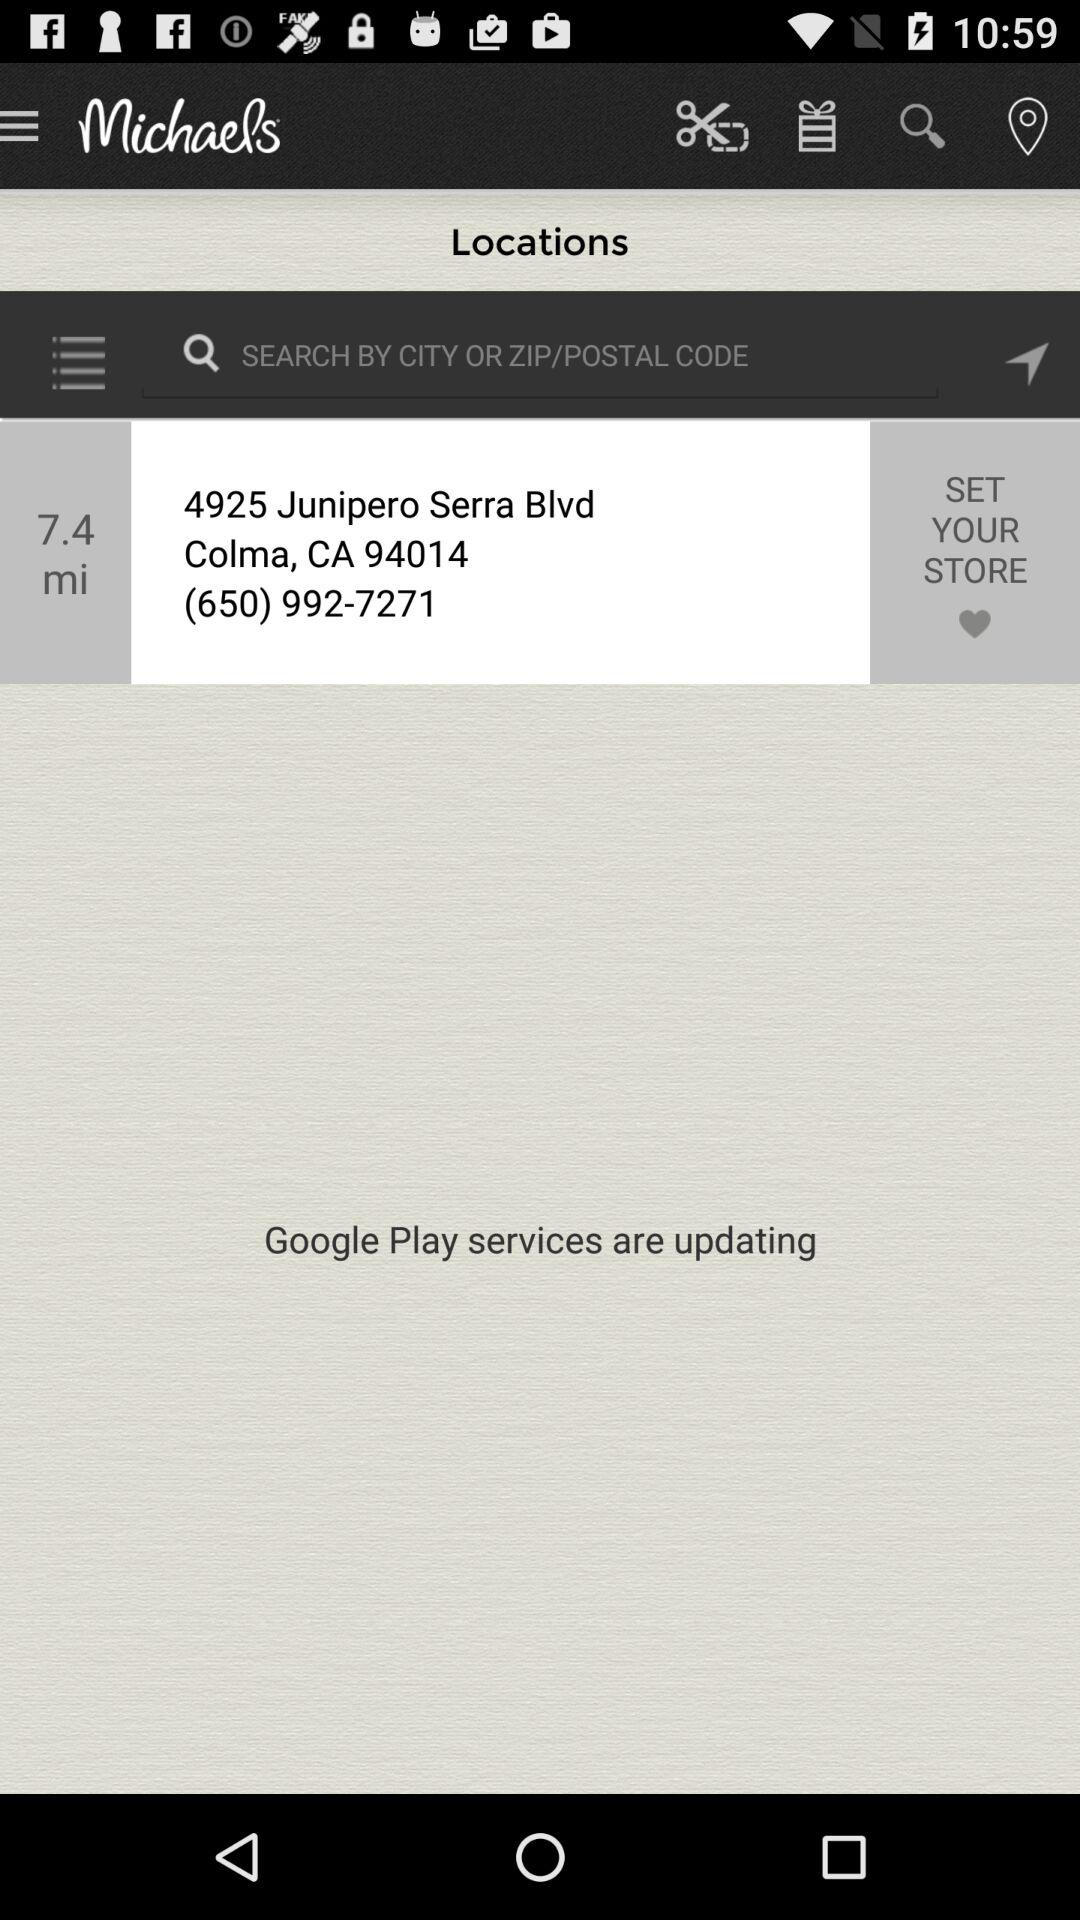What is the distance from the given location? The distance from the given location is 7.4 miles. 